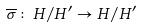Convert formula to latex. <formula><loc_0><loc_0><loc_500><loc_500>\overline { \sigma } \colon H / H ^ { \prime } \rightarrow H / H ^ { \prime }</formula> 